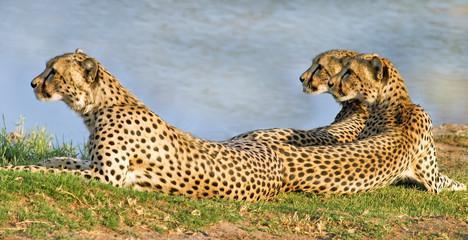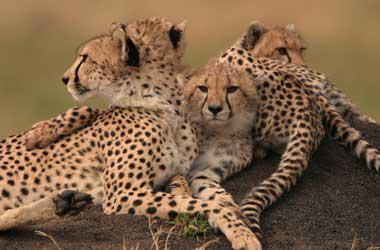The first image is the image on the left, the second image is the image on the right. Analyze the images presented: Is the assertion "Right image shows three cheetahs looking in a variety of directions." valid? Answer yes or no. No. 